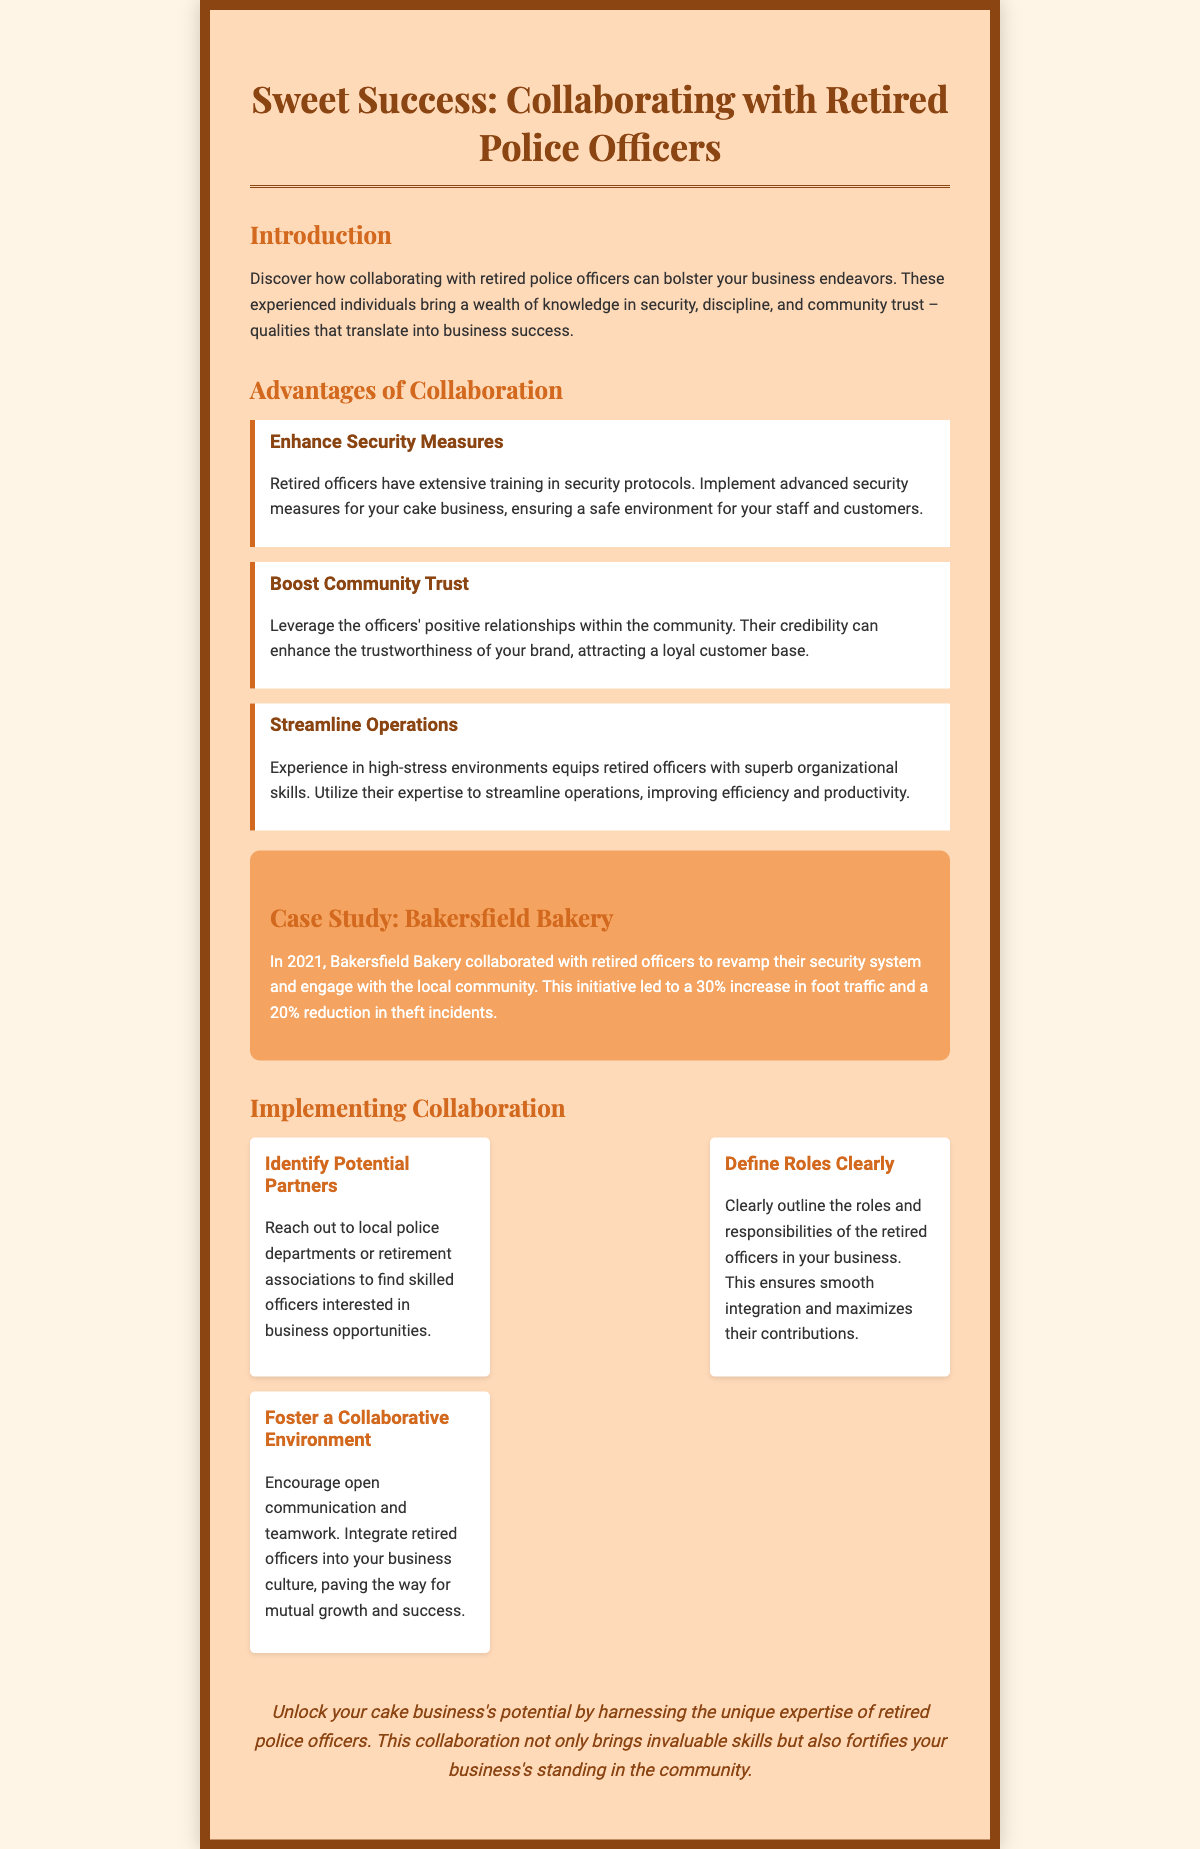What is the title of the document? The title is displayed prominently at the top of the Playbill section, naming the collaboration theme.
Answer: Sweet Success: Collaborating with Retired Police Officers What year did Bakersfield Bakery collaborate with retired officers? The specific year of collaboration is mentioned in the case study section of the document.
Answer: 2021 What percentage increase in foot traffic did Bakersfield Bakery experience? The document provides a specific percentage increase in foot traffic after the collaboration.
Answer: 30% What are the three advantages of collaboration listed in the document? The document outlines three key benefits of collaborating with retired police officers.
Answer: Enhance Security Measures, Boost Community Trust, Streamline Operations What should be defined clearly in collaboration implementation? This aspect is specifically mentioned in the implementation section regarding roles and responsibilities.
Answer: Roles What does fostering a collaborative environment encourage? The document emphasizes the importance of open communication in the business context.
Answer: Open Communication What color is the background of the Playbill? The overall background color is stated in the style section of the document.
Answer: #FFF5E6 What is the primary theme of the case study section? The case study emphasizes a specific collaboration result in the bakery business.
Answer: Increased foot traffic and reduced theft What is a suggested first step in implementing collaboration? The document provides an initial action item to initiate collaboration with retired officers.
Answer: Identify Potential Partners 